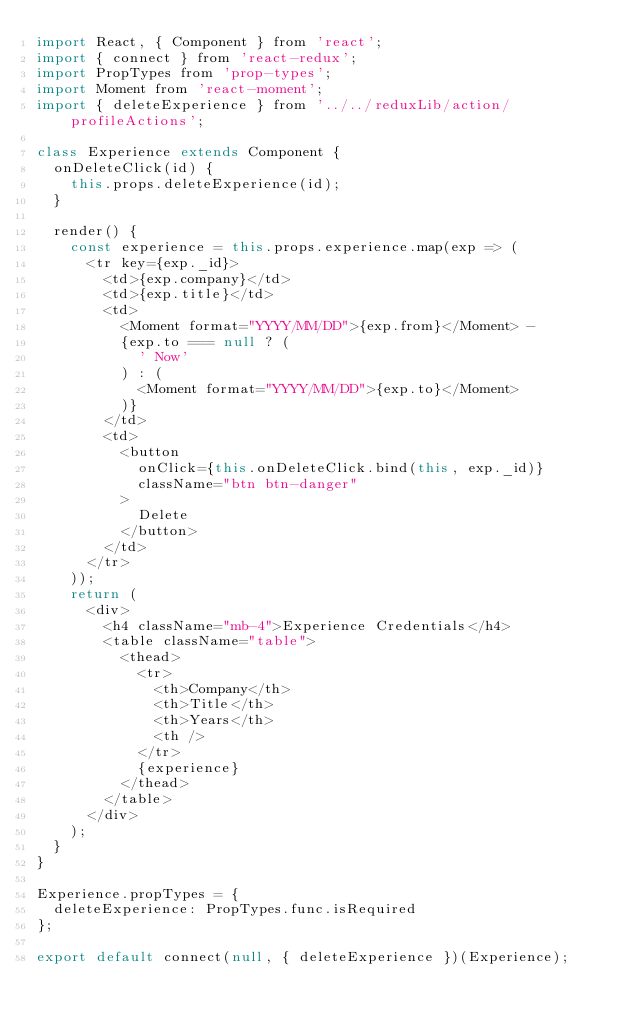Convert code to text. <code><loc_0><loc_0><loc_500><loc_500><_JavaScript_>import React, { Component } from 'react';
import { connect } from 'react-redux';
import PropTypes from 'prop-types';
import Moment from 'react-moment';
import { deleteExperience } from '../../reduxLib/action/profileActions';

class Experience extends Component {
  onDeleteClick(id) {
    this.props.deleteExperience(id);
  }

  render() {
    const experience = this.props.experience.map(exp => (
      <tr key={exp._id}>
        <td>{exp.company}</td>
        <td>{exp.title}</td>
        <td>
          <Moment format="YYYY/MM/DD">{exp.from}</Moment> -
          {exp.to === null ? (
            ' Now'
          ) : (
            <Moment format="YYYY/MM/DD">{exp.to}</Moment>
          )}
        </td>
        <td>
          <button
            onClick={this.onDeleteClick.bind(this, exp._id)}
            className="btn btn-danger"
          >
            Delete
          </button>
        </td>
      </tr>
    ));
    return (
      <div>
        <h4 className="mb-4">Experience Credentials</h4>
        <table className="table">
          <thead>
            <tr>
              <th>Company</th>
              <th>Title</th>
              <th>Years</th>
              <th />
            </tr>
            {experience}
          </thead>
        </table>
      </div>
    );
  }
}

Experience.propTypes = {
  deleteExperience: PropTypes.func.isRequired
};

export default connect(null, { deleteExperience })(Experience);
</code> 